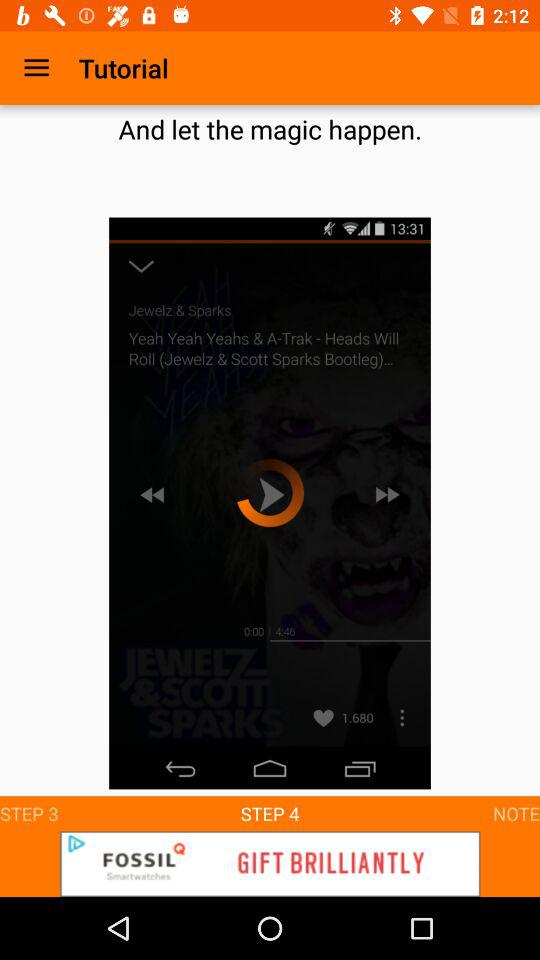What is the application name?
When the provided information is insufficient, respond with <no answer>. <no answer> 